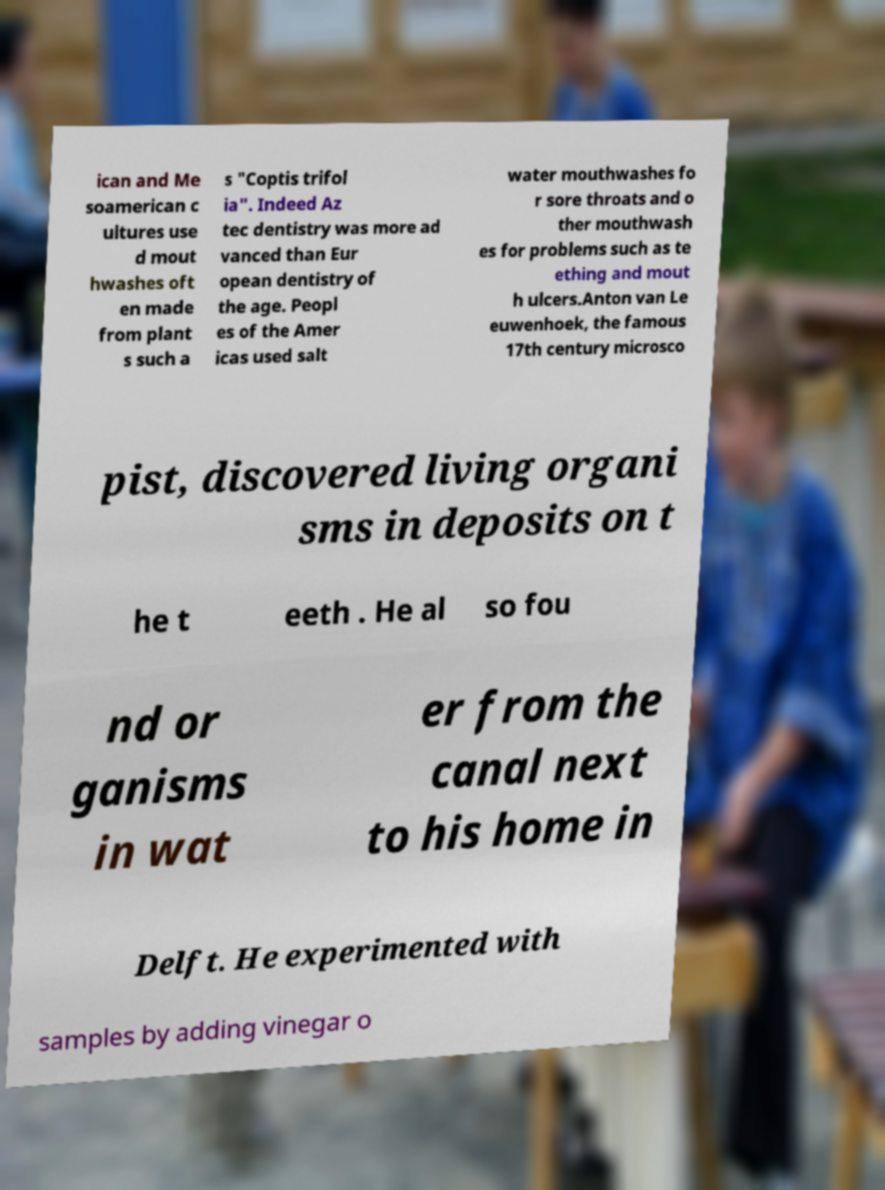Please identify and transcribe the text found in this image. ican and Me soamerican c ultures use d mout hwashes oft en made from plant s such a s "Coptis trifol ia". Indeed Az tec dentistry was more ad vanced than Eur opean dentistry of the age. Peopl es of the Amer icas used salt water mouthwashes fo r sore throats and o ther mouthwash es for problems such as te ething and mout h ulcers.Anton van Le euwenhoek, the famous 17th century microsco pist, discovered living organi sms in deposits on t he t eeth . He al so fou nd or ganisms in wat er from the canal next to his home in Delft. He experimented with samples by adding vinegar o 